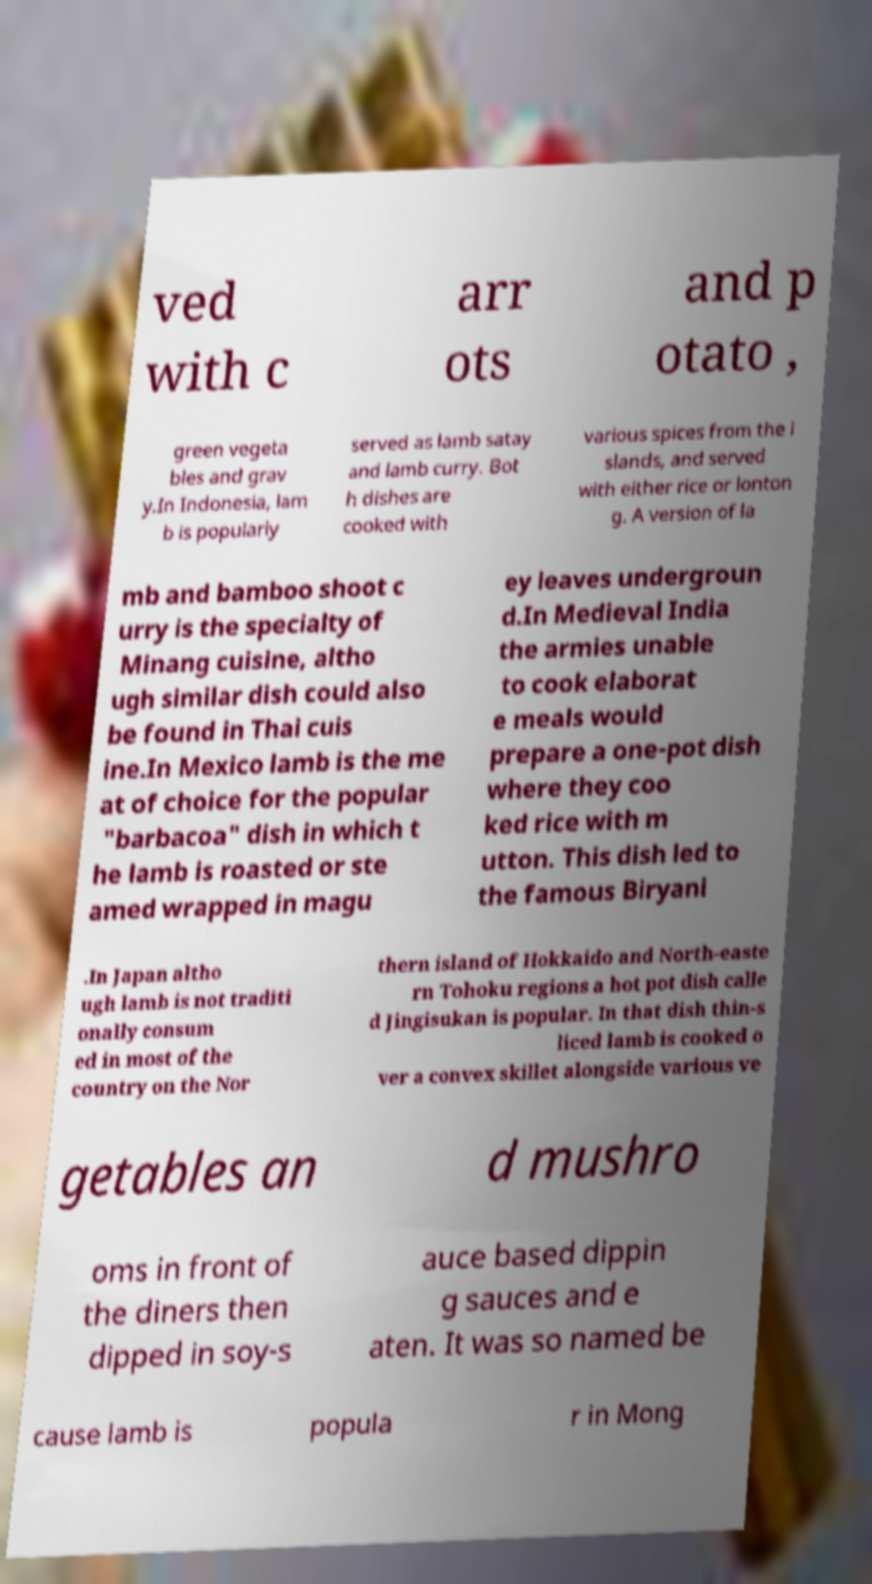What messages or text are displayed in this image? I need them in a readable, typed format. ved with c arr ots and p otato , green vegeta bles and grav y.In Indonesia, lam b is popularly served as lamb satay and lamb curry. Bot h dishes are cooked with various spices from the i slands, and served with either rice or lonton g. A version of la mb and bamboo shoot c urry is the specialty of Minang cuisine, altho ugh similar dish could also be found in Thai cuis ine.In Mexico lamb is the me at of choice for the popular "barbacoa" dish in which t he lamb is roasted or ste amed wrapped in magu ey leaves undergroun d.In Medieval India the armies unable to cook elaborat e meals would prepare a one-pot dish where they coo ked rice with m utton. This dish led to the famous Biryani .In Japan altho ugh lamb is not traditi onally consum ed in most of the country on the Nor thern island of Hokkaido and North-easte rn Tohoku regions a hot pot dish calle d Jingisukan is popular. In that dish thin-s liced lamb is cooked o ver a convex skillet alongside various ve getables an d mushro oms in front of the diners then dipped in soy-s auce based dippin g sauces and e aten. It was so named be cause lamb is popula r in Mong 